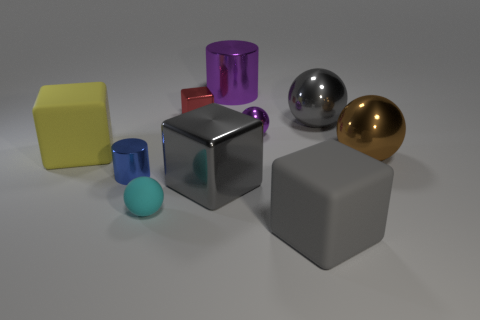What material is the tiny cyan sphere?
Give a very brief answer. Rubber. What material is the cyan ball that is the same size as the blue cylinder?
Offer a very short reply. Rubber. Does the cylinder that is in front of the brown shiny sphere have the same size as the red metallic thing?
Make the answer very short. Yes. Is the shape of the gray metal object in front of the yellow object the same as  the big brown metallic object?
Provide a short and direct response. No. How many objects are either gray spheres or big gray things that are behind the small blue shiny cylinder?
Provide a short and direct response. 1. Are there fewer tiny blue metallic objects than large gray things?
Provide a succinct answer. Yes. Is the number of big matte cubes greater than the number of big purple shiny cylinders?
Your answer should be very brief. Yes. What number of other objects are there of the same material as the purple cylinder?
Offer a terse response. 6. There is a big matte object in front of the metal cylinder that is left of the big purple metal object; how many big gray metallic things are on the right side of it?
Your response must be concise. 1. What number of metallic things are brown balls or large gray blocks?
Offer a very short reply. 2. 